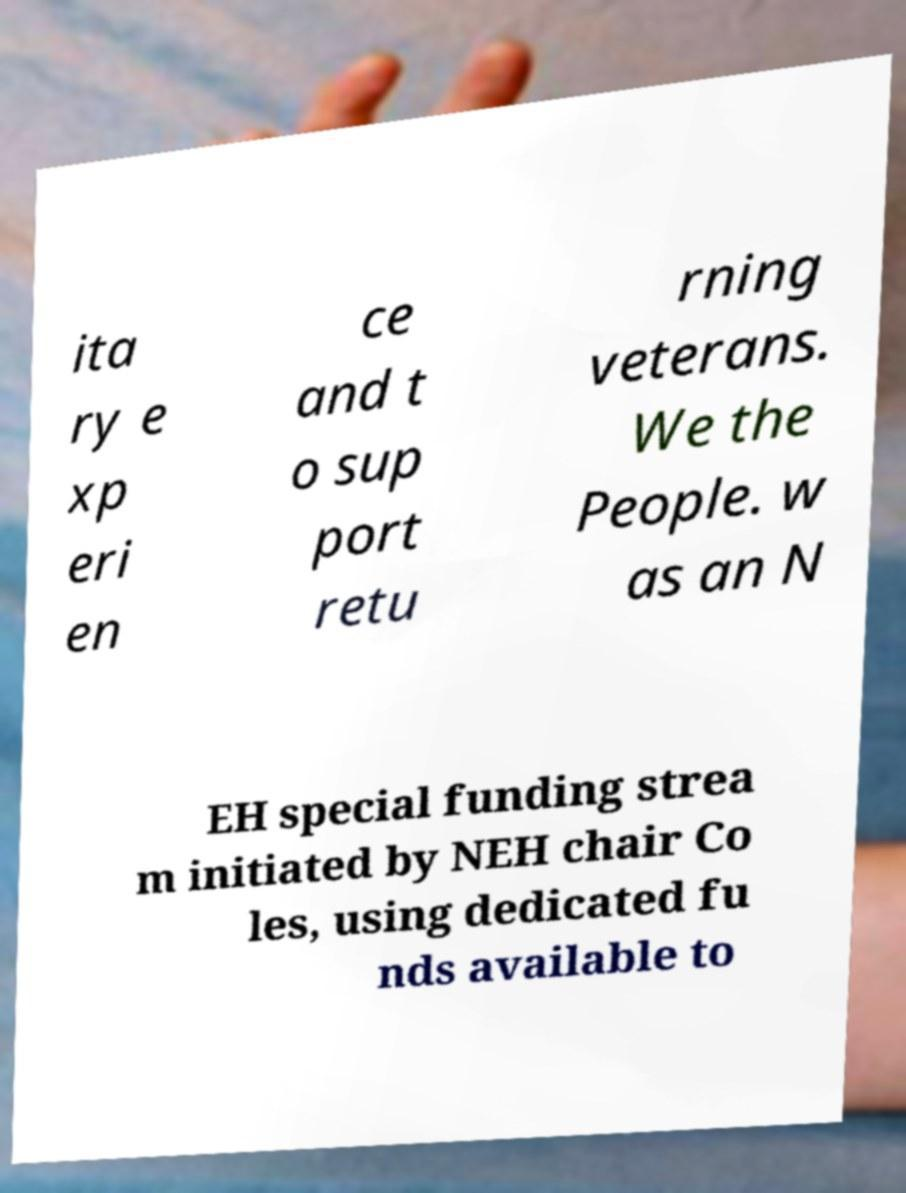What messages or text are displayed in this image? I need them in a readable, typed format. ita ry e xp eri en ce and t o sup port retu rning veterans. We the People. w as an N EH special funding strea m initiated by NEH chair Co les, using dedicated fu nds available to 